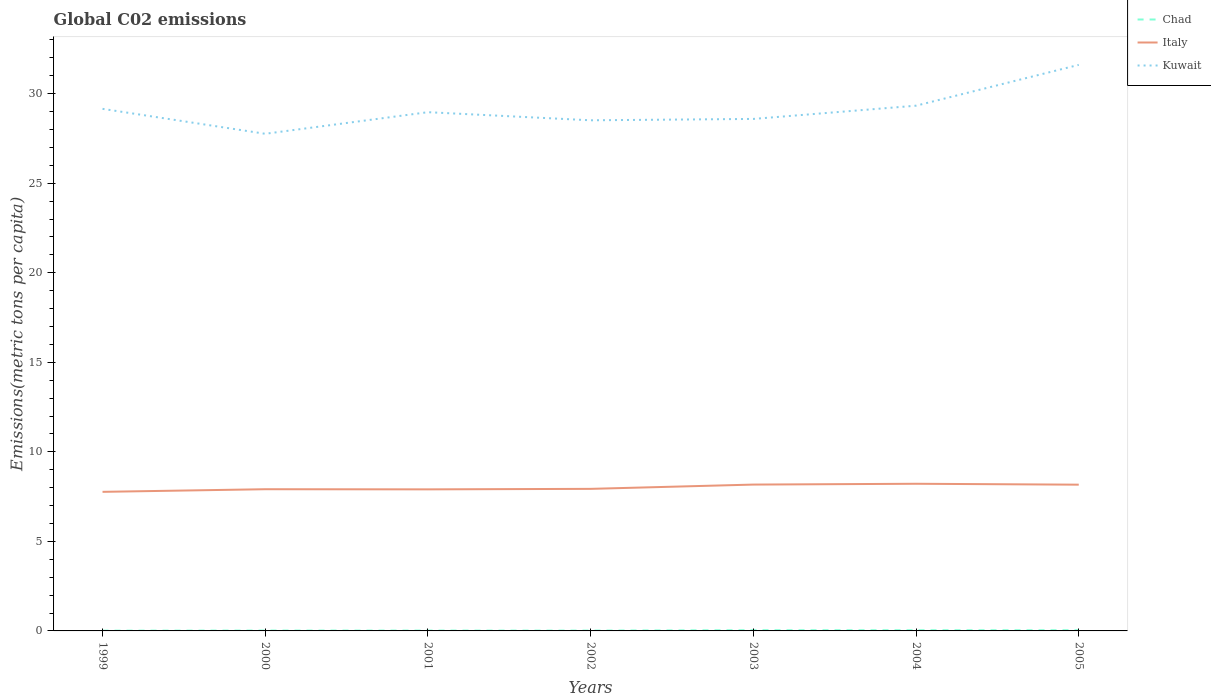How many different coloured lines are there?
Ensure brevity in your answer.  3. Is the number of lines equal to the number of legend labels?
Ensure brevity in your answer.  Yes. Across all years, what is the maximum amount of CO2 emitted in in Chad?
Provide a short and direct response. 0.02. In which year was the amount of CO2 emitted in in Italy maximum?
Keep it short and to the point. 1999. What is the total amount of CO2 emitted in in Italy in the graph?
Make the answer very short. -0.25. What is the difference between the highest and the second highest amount of CO2 emitted in in Chad?
Offer a terse response. 0.03. Is the amount of CO2 emitted in in Kuwait strictly greater than the amount of CO2 emitted in in Italy over the years?
Offer a terse response. No. How many lines are there?
Provide a short and direct response. 3. Are the values on the major ticks of Y-axis written in scientific E-notation?
Provide a succinct answer. No. Does the graph contain grids?
Offer a terse response. No. Where does the legend appear in the graph?
Ensure brevity in your answer.  Top right. How many legend labels are there?
Give a very brief answer. 3. What is the title of the graph?
Your answer should be very brief. Global C02 emissions. Does "Dominica" appear as one of the legend labels in the graph?
Offer a very short reply. No. What is the label or title of the X-axis?
Provide a succinct answer. Years. What is the label or title of the Y-axis?
Keep it short and to the point. Emissions(metric tons per capita). What is the Emissions(metric tons per capita) in Chad in 1999?
Your answer should be compact. 0.02. What is the Emissions(metric tons per capita) in Italy in 1999?
Your answer should be compact. 7.77. What is the Emissions(metric tons per capita) in Kuwait in 1999?
Provide a short and direct response. 29.15. What is the Emissions(metric tons per capita) of Chad in 2000?
Your answer should be compact. 0.02. What is the Emissions(metric tons per capita) of Italy in 2000?
Your response must be concise. 7.91. What is the Emissions(metric tons per capita) in Kuwait in 2000?
Provide a short and direct response. 27.76. What is the Emissions(metric tons per capita) of Chad in 2001?
Offer a terse response. 0.02. What is the Emissions(metric tons per capita) of Italy in 2001?
Keep it short and to the point. 7.9. What is the Emissions(metric tons per capita) of Kuwait in 2001?
Make the answer very short. 28.97. What is the Emissions(metric tons per capita) of Chad in 2002?
Provide a short and direct response. 0.02. What is the Emissions(metric tons per capita) in Italy in 2002?
Provide a succinct answer. 7.93. What is the Emissions(metric tons per capita) in Kuwait in 2002?
Offer a very short reply. 28.51. What is the Emissions(metric tons per capita) of Chad in 2003?
Offer a terse response. 0.04. What is the Emissions(metric tons per capita) of Italy in 2003?
Keep it short and to the point. 8.17. What is the Emissions(metric tons per capita) of Kuwait in 2003?
Your response must be concise. 28.59. What is the Emissions(metric tons per capita) in Chad in 2004?
Make the answer very short. 0.04. What is the Emissions(metric tons per capita) of Italy in 2004?
Your response must be concise. 8.22. What is the Emissions(metric tons per capita) in Kuwait in 2004?
Give a very brief answer. 29.33. What is the Emissions(metric tons per capita) in Chad in 2005?
Your response must be concise. 0.04. What is the Emissions(metric tons per capita) in Italy in 2005?
Provide a succinct answer. 8.17. What is the Emissions(metric tons per capita) of Kuwait in 2005?
Offer a very short reply. 31.61. Across all years, what is the maximum Emissions(metric tons per capita) in Chad?
Provide a succinct answer. 0.04. Across all years, what is the maximum Emissions(metric tons per capita) in Italy?
Your answer should be compact. 8.22. Across all years, what is the maximum Emissions(metric tons per capita) in Kuwait?
Provide a succinct answer. 31.61. Across all years, what is the minimum Emissions(metric tons per capita) of Chad?
Keep it short and to the point. 0.02. Across all years, what is the minimum Emissions(metric tons per capita) of Italy?
Offer a very short reply. 7.77. Across all years, what is the minimum Emissions(metric tons per capita) in Kuwait?
Ensure brevity in your answer.  27.76. What is the total Emissions(metric tons per capita) in Chad in the graph?
Your answer should be compact. 0.19. What is the total Emissions(metric tons per capita) in Italy in the graph?
Your answer should be compact. 56.07. What is the total Emissions(metric tons per capita) in Kuwait in the graph?
Your answer should be compact. 203.91. What is the difference between the Emissions(metric tons per capita) in Chad in 1999 and that in 2000?
Your answer should be very brief. -0.01. What is the difference between the Emissions(metric tons per capita) of Italy in 1999 and that in 2000?
Your answer should be compact. -0.15. What is the difference between the Emissions(metric tons per capita) of Kuwait in 1999 and that in 2000?
Your response must be concise. 1.39. What is the difference between the Emissions(metric tons per capita) in Chad in 1999 and that in 2001?
Give a very brief answer. -0. What is the difference between the Emissions(metric tons per capita) of Italy in 1999 and that in 2001?
Ensure brevity in your answer.  -0.14. What is the difference between the Emissions(metric tons per capita) of Kuwait in 1999 and that in 2001?
Ensure brevity in your answer.  0.19. What is the difference between the Emissions(metric tons per capita) in Chad in 1999 and that in 2002?
Provide a short and direct response. -0. What is the difference between the Emissions(metric tons per capita) in Italy in 1999 and that in 2002?
Your answer should be very brief. -0.17. What is the difference between the Emissions(metric tons per capita) of Kuwait in 1999 and that in 2002?
Offer a terse response. 0.64. What is the difference between the Emissions(metric tons per capita) of Chad in 1999 and that in 2003?
Give a very brief answer. -0.03. What is the difference between the Emissions(metric tons per capita) in Italy in 1999 and that in 2003?
Keep it short and to the point. -0.41. What is the difference between the Emissions(metric tons per capita) in Kuwait in 1999 and that in 2003?
Your answer should be very brief. 0.56. What is the difference between the Emissions(metric tons per capita) of Chad in 1999 and that in 2004?
Your answer should be compact. -0.02. What is the difference between the Emissions(metric tons per capita) of Italy in 1999 and that in 2004?
Give a very brief answer. -0.45. What is the difference between the Emissions(metric tons per capita) in Kuwait in 1999 and that in 2004?
Your answer should be very brief. -0.18. What is the difference between the Emissions(metric tons per capita) of Chad in 1999 and that in 2005?
Provide a short and direct response. -0.02. What is the difference between the Emissions(metric tons per capita) of Italy in 1999 and that in 2005?
Your answer should be very brief. -0.4. What is the difference between the Emissions(metric tons per capita) of Kuwait in 1999 and that in 2005?
Your response must be concise. -2.46. What is the difference between the Emissions(metric tons per capita) of Chad in 2000 and that in 2001?
Offer a very short reply. 0. What is the difference between the Emissions(metric tons per capita) of Italy in 2000 and that in 2001?
Offer a very short reply. 0.01. What is the difference between the Emissions(metric tons per capita) of Kuwait in 2000 and that in 2001?
Keep it short and to the point. -1.21. What is the difference between the Emissions(metric tons per capita) in Chad in 2000 and that in 2002?
Your answer should be very brief. 0. What is the difference between the Emissions(metric tons per capita) in Italy in 2000 and that in 2002?
Offer a terse response. -0.02. What is the difference between the Emissions(metric tons per capita) of Kuwait in 2000 and that in 2002?
Your response must be concise. -0.75. What is the difference between the Emissions(metric tons per capita) in Chad in 2000 and that in 2003?
Give a very brief answer. -0.02. What is the difference between the Emissions(metric tons per capita) of Italy in 2000 and that in 2003?
Your answer should be very brief. -0.26. What is the difference between the Emissions(metric tons per capita) in Kuwait in 2000 and that in 2003?
Provide a succinct answer. -0.83. What is the difference between the Emissions(metric tons per capita) of Chad in 2000 and that in 2004?
Make the answer very short. -0.02. What is the difference between the Emissions(metric tons per capita) of Italy in 2000 and that in 2004?
Offer a very short reply. -0.3. What is the difference between the Emissions(metric tons per capita) in Kuwait in 2000 and that in 2004?
Make the answer very short. -1.57. What is the difference between the Emissions(metric tons per capita) of Chad in 2000 and that in 2005?
Offer a very short reply. -0.02. What is the difference between the Emissions(metric tons per capita) in Italy in 2000 and that in 2005?
Your answer should be very brief. -0.25. What is the difference between the Emissions(metric tons per capita) in Kuwait in 2000 and that in 2005?
Your answer should be very brief. -3.85. What is the difference between the Emissions(metric tons per capita) in Chad in 2001 and that in 2002?
Your answer should be very brief. 0. What is the difference between the Emissions(metric tons per capita) of Italy in 2001 and that in 2002?
Offer a terse response. -0.03. What is the difference between the Emissions(metric tons per capita) of Kuwait in 2001 and that in 2002?
Make the answer very short. 0.45. What is the difference between the Emissions(metric tons per capita) of Chad in 2001 and that in 2003?
Offer a very short reply. -0.02. What is the difference between the Emissions(metric tons per capita) in Italy in 2001 and that in 2003?
Give a very brief answer. -0.27. What is the difference between the Emissions(metric tons per capita) of Kuwait in 2001 and that in 2003?
Provide a short and direct response. 0.38. What is the difference between the Emissions(metric tons per capita) of Chad in 2001 and that in 2004?
Your response must be concise. -0.02. What is the difference between the Emissions(metric tons per capita) in Italy in 2001 and that in 2004?
Your answer should be compact. -0.31. What is the difference between the Emissions(metric tons per capita) in Kuwait in 2001 and that in 2004?
Keep it short and to the point. -0.36. What is the difference between the Emissions(metric tons per capita) in Chad in 2001 and that in 2005?
Your response must be concise. -0.02. What is the difference between the Emissions(metric tons per capita) in Italy in 2001 and that in 2005?
Ensure brevity in your answer.  -0.26. What is the difference between the Emissions(metric tons per capita) in Kuwait in 2001 and that in 2005?
Your response must be concise. -2.64. What is the difference between the Emissions(metric tons per capita) of Chad in 2002 and that in 2003?
Your answer should be compact. -0.02. What is the difference between the Emissions(metric tons per capita) of Italy in 2002 and that in 2003?
Give a very brief answer. -0.24. What is the difference between the Emissions(metric tons per capita) in Kuwait in 2002 and that in 2003?
Your answer should be compact. -0.08. What is the difference between the Emissions(metric tons per capita) of Chad in 2002 and that in 2004?
Your answer should be compact. -0.02. What is the difference between the Emissions(metric tons per capita) of Italy in 2002 and that in 2004?
Give a very brief answer. -0.28. What is the difference between the Emissions(metric tons per capita) in Kuwait in 2002 and that in 2004?
Provide a succinct answer. -0.82. What is the difference between the Emissions(metric tons per capita) in Chad in 2002 and that in 2005?
Make the answer very short. -0.02. What is the difference between the Emissions(metric tons per capita) of Italy in 2002 and that in 2005?
Keep it short and to the point. -0.23. What is the difference between the Emissions(metric tons per capita) in Kuwait in 2002 and that in 2005?
Your answer should be very brief. -3.1. What is the difference between the Emissions(metric tons per capita) of Chad in 2003 and that in 2004?
Your answer should be compact. 0. What is the difference between the Emissions(metric tons per capita) in Italy in 2003 and that in 2004?
Offer a terse response. -0.04. What is the difference between the Emissions(metric tons per capita) of Kuwait in 2003 and that in 2004?
Your answer should be very brief. -0.74. What is the difference between the Emissions(metric tons per capita) in Chad in 2003 and that in 2005?
Provide a short and direct response. 0. What is the difference between the Emissions(metric tons per capita) in Italy in 2003 and that in 2005?
Provide a succinct answer. 0.01. What is the difference between the Emissions(metric tons per capita) of Kuwait in 2003 and that in 2005?
Your response must be concise. -3.02. What is the difference between the Emissions(metric tons per capita) of Chad in 2004 and that in 2005?
Offer a terse response. -0. What is the difference between the Emissions(metric tons per capita) of Italy in 2004 and that in 2005?
Your response must be concise. 0.05. What is the difference between the Emissions(metric tons per capita) in Kuwait in 2004 and that in 2005?
Keep it short and to the point. -2.28. What is the difference between the Emissions(metric tons per capita) of Chad in 1999 and the Emissions(metric tons per capita) of Italy in 2000?
Your answer should be compact. -7.9. What is the difference between the Emissions(metric tons per capita) in Chad in 1999 and the Emissions(metric tons per capita) in Kuwait in 2000?
Provide a succinct answer. -27.74. What is the difference between the Emissions(metric tons per capita) in Italy in 1999 and the Emissions(metric tons per capita) in Kuwait in 2000?
Provide a succinct answer. -19.99. What is the difference between the Emissions(metric tons per capita) in Chad in 1999 and the Emissions(metric tons per capita) in Italy in 2001?
Your response must be concise. -7.89. What is the difference between the Emissions(metric tons per capita) in Chad in 1999 and the Emissions(metric tons per capita) in Kuwait in 2001?
Provide a succinct answer. -28.95. What is the difference between the Emissions(metric tons per capita) in Italy in 1999 and the Emissions(metric tons per capita) in Kuwait in 2001?
Your response must be concise. -21.2. What is the difference between the Emissions(metric tons per capita) in Chad in 1999 and the Emissions(metric tons per capita) in Italy in 2002?
Your answer should be compact. -7.92. What is the difference between the Emissions(metric tons per capita) of Chad in 1999 and the Emissions(metric tons per capita) of Kuwait in 2002?
Ensure brevity in your answer.  -28.5. What is the difference between the Emissions(metric tons per capita) of Italy in 1999 and the Emissions(metric tons per capita) of Kuwait in 2002?
Provide a succinct answer. -20.75. What is the difference between the Emissions(metric tons per capita) in Chad in 1999 and the Emissions(metric tons per capita) in Italy in 2003?
Offer a very short reply. -8.16. What is the difference between the Emissions(metric tons per capita) in Chad in 1999 and the Emissions(metric tons per capita) in Kuwait in 2003?
Keep it short and to the point. -28.57. What is the difference between the Emissions(metric tons per capita) of Italy in 1999 and the Emissions(metric tons per capita) of Kuwait in 2003?
Offer a terse response. -20.82. What is the difference between the Emissions(metric tons per capita) in Chad in 1999 and the Emissions(metric tons per capita) in Italy in 2004?
Offer a very short reply. -8.2. What is the difference between the Emissions(metric tons per capita) in Chad in 1999 and the Emissions(metric tons per capita) in Kuwait in 2004?
Give a very brief answer. -29.31. What is the difference between the Emissions(metric tons per capita) in Italy in 1999 and the Emissions(metric tons per capita) in Kuwait in 2004?
Keep it short and to the point. -21.56. What is the difference between the Emissions(metric tons per capita) of Chad in 1999 and the Emissions(metric tons per capita) of Italy in 2005?
Your answer should be compact. -8.15. What is the difference between the Emissions(metric tons per capita) of Chad in 1999 and the Emissions(metric tons per capita) of Kuwait in 2005?
Provide a short and direct response. -31.59. What is the difference between the Emissions(metric tons per capita) of Italy in 1999 and the Emissions(metric tons per capita) of Kuwait in 2005?
Provide a short and direct response. -23.84. What is the difference between the Emissions(metric tons per capita) of Chad in 2000 and the Emissions(metric tons per capita) of Italy in 2001?
Keep it short and to the point. -7.88. What is the difference between the Emissions(metric tons per capita) of Chad in 2000 and the Emissions(metric tons per capita) of Kuwait in 2001?
Keep it short and to the point. -28.94. What is the difference between the Emissions(metric tons per capita) in Italy in 2000 and the Emissions(metric tons per capita) in Kuwait in 2001?
Your response must be concise. -21.05. What is the difference between the Emissions(metric tons per capita) in Chad in 2000 and the Emissions(metric tons per capita) in Italy in 2002?
Make the answer very short. -7.91. What is the difference between the Emissions(metric tons per capita) of Chad in 2000 and the Emissions(metric tons per capita) of Kuwait in 2002?
Ensure brevity in your answer.  -28.49. What is the difference between the Emissions(metric tons per capita) in Italy in 2000 and the Emissions(metric tons per capita) in Kuwait in 2002?
Your answer should be very brief. -20.6. What is the difference between the Emissions(metric tons per capita) of Chad in 2000 and the Emissions(metric tons per capita) of Italy in 2003?
Offer a terse response. -8.15. What is the difference between the Emissions(metric tons per capita) in Chad in 2000 and the Emissions(metric tons per capita) in Kuwait in 2003?
Your answer should be very brief. -28.57. What is the difference between the Emissions(metric tons per capita) in Italy in 2000 and the Emissions(metric tons per capita) in Kuwait in 2003?
Offer a terse response. -20.68. What is the difference between the Emissions(metric tons per capita) in Chad in 2000 and the Emissions(metric tons per capita) in Italy in 2004?
Offer a terse response. -8.2. What is the difference between the Emissions(metric tons per capita) in Chad in 2000 and the Emissions(metric tons per capita) in Kuwait in 2004?
Your answer should be very brief. -29.31. What is the difference between the Emissions(metric tons per capita) of Italy in 2000 and the Emissions(metric tons per capita) of Kuwait in 2004?
Give a very brief answer. -21.42. What is the difference between the Emissions(metric tons per capita) of Chad in 2000 and the Emissions(metric tons per capita) of Italy in 2005?
Give a very brief answer. -8.14. What is the difference between the Emissions(metric tons per capita) of Chad in 2000 and the Emissions(metric tons per capita) of Kuwait in 2005?
Your answer should be very brief. -31.59. What is the difference between the Emissions(metric tons per capita) in Italy in 2000 and the Emissions(metric tons per capita) in Kuwait in 2005?
Offer a very short reply. -23.69. What is the difference between the Emissions(metric tons per capita) in Chad in 2001 and the Emissions(metric tons per capita) in Italy in 2002?
Provide a succinct answer. -7.91. What is the difference between the Emissions(metric tons per capita) of Chad in 2001 and the Emissions(metric tons per capita) of Kuwait in 2002?
Give a very brief answer. -28.49. What is the difference between the Emissions(metric tons per capita) of Italy in 2001 and the Emissions(metric tons per capita) of Kuwait in 2002?
Provide a short and direct response. -20.61. What is the difference between the Emissions(metric tons per capita) of Chad in 2001 and the Emissions(metric tons per capita) of Italy in 2003?
Your answer should be very brief. -8.15. What is the difference between the Emissions(metric tons per capita) in Chad in 2001 and the Emissions(metric tons per capita) in Kuwait in 2003?
Your answer should be compact. -28.57. What is the difference between the Emissions(metric tons per capita) in Italy in 2001 and the Emissions(metric tons per capita) in Kuwait in 2003?
Offer a very short reply. -20.68. What is the difference between the Emissions(metric tons per capita) of Chad in 2001 and the Emissions(metric tons per capita) of Italy in 2004?
Offer a very short reply. -8.2. What is the difference between the Emissions(metric tons per capita) of Chad in 2001 and the Emissions(metric tons per capita) of Kuwait in 2004?
Make the answer very short. -29.31. What is the difference between the Emissions(metric tons per capita) in Italy in 2001 and the Emissions(metric tons per capita) in Kuwait in 2004?
Ensure brevity in your answer.  -21.42. What is the difference between the Emissions(metric tons per capita) in Chad in 2001 and the Emissions(metric tons per capita) in Italy in 2005?
Give a very brief answer. -8.15. What is the difference between the Emissions(metric tons per capita) in Chad in 2001 and the Emissions(metric tons per capita) in Kuwait in 2005?
Your response must be concise. -31.59. What is the difference between the Emissions(metric tons per capita) in Italy in 2001 and the Emissions(metric tons per capita) in Kuwait in 2005?
Your answer should be compact. -23.7. What is the difference between the Emissions(metric tons per capita) in Chad in 2002 and the Emissions(metric tons per capita) in Italy in 2003?
Provide a short and direct response. -8.15. What is the difference between the Emissions(metric tons per capita) of Chad in 2002 and the Emissions(metric tons per capita) of Kuwait in 2003?
Offer a very short reply. -28.57. What is the difference between the Emissions(metric tons per capita) of Italy in 2002 and the Emissions(metric tons per capita) of Kuwait in 2003?
Give a very brief answer. -20.66. What is the difference between the Emissions(metric tons per capita) of Chad in 2002 and the Emissions(metric tons per capita) of Italy in 2004?
Offer a very short reply. -8.2. What is the difference between the Emissions(metric tons per capita) of Chad in 2002 and the Emissions(metric tons per capita) of Kuwait in 2004?
Your answer should be very brief. -29.31. What is the difference between the Emissions(metric tons per capita) of Italy in 2002 and the Emissions(metric tons per capita) of Kuwait in 2004?
Provide a short and direct response. -21.4. What is the difference between the Emissions(metric tons per capita) in Chad in 2002 and the Emissions(metric tons per capita) in Italy in 2005?
Your answer should be very brief. -8.15. What is the difference between the Emissions(metric tons per capita) of Chad in 2002 and the Emissions(metric tons per capita) of Kuwait in 2005?
Ensure brevity in your answer.  -31.59. What is the difference between the Emissions(metric tons per capita) in Italy in 2002 and the Emissions(metric tons per capita) in Kuwait in 2005?
Offer a terse response. -23.68. What is the difference between the Emissions(metric tons per capita) in Chad in 2003 and the Emissions(metric tons per capita) in Italy in 2004?
Your response must be concise. -8.18. What is the difference between the Emissions(metric tons per capita) in Chad in 2003 and the Emissions(metric tons per capita) in Kuwait in 2004?
Your response must be concise. -29.29. What is the difference between the Emissions(metric tons per capita) of Italy in 2003 and the Emissions(metric tons per capita) of Kuwait in 2004?
Make the answer very short. -21.16. What is the difference between the Emissions(metric tons per capita) in Chad in 2003 and the Emissions(metric tons per capita) in Italy in 2005?
Keep it short and to the point. -8.13. What is the difference between the Emissions(metric tons per capita) in Chad in 2003 and the Emissions(metric tons per capita) in Kuwait in 2005?
Your answer should be compact. -31.57. What is the difference between the Emissions(metric tons per capita) in Italy in 2003 and the Emissions(metric tons per capita) in Kuwait in 2005?
Provide a short and direct response. -23.44. What is the difference between the Emissions(metric tons per capita) in Chad in 2004 and the Emissions(metric tons per capita) in Italy in 2005?
Provide a short and direct response. -8.13. What is the difference between the Emissions(metric tons per capita) of Chad in 2004 and the Emissions(metric tons per capita) of Kuwait in 2005?
Give a very brief answer. -31.57. What is the difference between the Emissions(metric tons per capita) of Italy in 2004 and the Emissions(metric tons per capita) of Kuwait in 2005?
Provide a short and direct response. -23.39. What is the average Emissions(metric tons per capita) in Chad per year?
Make the answer very short. 0.03. What is the average Emissions(metric tons per capita) of Italy per year?
Keep it short and to the point. 8.01. What is the average Emissions(metric tons per capita) of Kuwait per year?
Provide a succinct answer. 29.13. In the year 1999, what is the difference between the Emissions(metric tons per capita) of Chad and Emissions(metric tons per capita) of Italy?
Keep it short and to the point. -7.75. In the year 1999, what is the difference between the Emissions(metric tons per capita) in Chad and Emissions(metric tons per capita) in Kuwait?
Give a very brief answer. -29.14. In the year 1999, what is the difference between the Emissions(metric tons per capita) in Italy and Emissions(metric tons per capita) in Kuwait?
Make the answer very short. -21.39. In the year 2000, what is the difference between the Emissions(metric tons per capita) of Chad and Emissions(metric tons per capita) of Italy?
Your answer should be very brief. -7.89. In the year 2000, what is the difference between the Emissions(metric tons per capita) of Chad and Emissions(metric tons per capita) of Kuwait?
Your answer should be very brief. -27.74. In the year 2000, what is the difference between the Emissions(metric tons per capita) in Italy and Emissions(metric tons per capita) in Kuwait?
Offer a very short reply. -19.85. In the year 2001, what is the difference between the Emissions(metric tons per capita) in Chad and Emissions(metric tons per capita) in Italy?
Give a very brief answer. -7.88. In the year 2001, what is the difference between the Emissions(metric tons per capita) of Chad and Emissions(metric tons per capita) of Kuwait?
Give a very brief answer. -28.95. In the year 2001, what is the difference between the Emissions(metric tons per capita) in Italy and Emissions(metric tons per capita) in Kuwait?
Your answer should be very brief. -21.06. In the year 2002, what is the difference between the Emissions(metric tons per capita) in Chad and Emissions(metric tons per capita) in Italy?
Your answer should be very brief. -7.91. In the year 2002, what is the difference between the Emissions(metric tons per capita) of Chad and Emissions(metric tons per capita) of Kuwait?
Give a very brief answer. -28.49. In the year 2002, what is the difference between the Emissions(metric tons per capita) of Italy and Emissions(metric tons per capita) of Kuwait?
Give a very brief answer. -20.58. In the year 2003, what is the difference between the Emissions(metric tons per capita) in Chad and Emissions(metric tons per capita) in Italy?
Provide a short and direct response. -8.13. In the year 2003, what is the difference between the Emissions(metric tons per capita) of Chad and Emissions(metric tons per capita) of Kuwait?
Make the answer very short. -28.55. In the year 2003, what is the difference between the Emissions(metric tons per capita) in Italy and Emissions(metric tons per capita) in Kuwait?
Your answer should be very brief. -20.42. In the year 2004, what is the difference between the Emissions(metric tons per capita) in Chad and Emissions(metric tons per capita) in Italy?
Ensure brevity in your answer.  -8.18. In the year 2004, what is the difference between the Emissions(metric tons per capita) in Chad and Emissions(metric tons per capita) in Kuwait?
Offer a terse response. -29.29. In the year 2004, what is the difference between the Emissions(metric tons per capita) of Italy and Emissions(metric tons per capita) of Kuwait?
Your answer should be compact. -21.11. In the year 2005, what is the difference between the Emissions(metric tons per capita) of Chad and Emissions(metric tons per capita) of Italy?
Your answer should be compact. -8.13. In the year 2005, what is the difference between the Emissions(metric tons per capita) of Chad and Emissions(metric tons per capita) of Kuwait?
Make the answer very short. -31.57. In the year 2005, what is the difference between the Emissions(metric tons per capita) in Italy and Emissions(metric tons per capita) in Kuwait?
Provide a succinct answer. -23.44. What is the ratio of the Emissions(metric tons per capita) in Chad in 1999 to that in 2000?
Offer a very short reply. 0.71. What is the ratio of the Emissions(metric tons per capita) of Italy in 1999 to that in 2000?
Ensure brevity in your answer.  0.98. What is the ratio of the Emissions(metric tons per capita) in Kuwait in 1999 to that in 2000?
Your answer should be very brief. 1.05. What is the ratio of the Emissions(metric tons per capita) in Chad in 1999 to that in 2001?
Make the answer very short. 0.76. What is the ratio of the Emissions(metric tons per capita) in Italy in 1999 to that in 2001?
Your response must be concise. 0.98. What is the ratio of the Emissions(metric tons per capita) of Kuwait in 1999 to that in 2001?
Provide a short and direct response. 1.01. What is the ratio of the Emissions(metric tons per capita) in Chad in 1999 to that in 2002?
Make the answer very short. 0.8. What is the ratio of the Emissions(metric tons per capita) in Kuwait in 1999 to that in 2002?
Your response must be concise. 1.02. What is the ratio of the Emissions(metric tons per capita) in Chad in 1999 to that in 2003?
Provide a short and direct response. 0.37. What is the ratio of the Emissions(metric tons per capita) of Italy in 1999 to that in 2003?
Provide a succinct answer. 0.95. What is the ratio of the Emissions(metric tons per capita) of Kuwait in 1999 to that in 2003?
Keep it short and to the point. 1.02. What is the ratio of the Emissions(metric tons per capita) of Chad in 1999 to that in 2004?
Offer a terse response. 0.39. What is the ratio of the Emissions(metric tons per capita) of Italy in 1999 to that in 2004?
Offer a very short reply. 0.95. What is the ratio of the Emissions(metric tons per capita) in Chad in 1999 to that in 2005?
Offer a terse response. 0.38. What is the ratio of the Emissions(metric tons per capita) of Italy in 1999 to that in 2005?
Make the answer very short. 0.95. What is the ratio of the Emissions(metric tons per capita) of Kuwait in 1999 to that in 2005?
Your response must be concise. 0.92. What is the ratio of the Emissions(metric tons per capita) in Chad in 2000 to that in 2001?
Offer a terse response. 1.06. What is the ratio of the Emissions(metric tons per capita) of Kuwait in 2000 to that in 2001?
Provide a short and direct response. 0.96. What is the ratio of the Emissions(metric tons per capita) of Chad in 2000 to that in 2002?
Your answer should be very brief. 1.13. What is the ratio of the Emissions(metric tons per capita) of Italy in 2000 to that in 2002?
Your answer should be very brief. 1. What is the ratio of the Emissions(metric tons per capita) of Kuwait in 2000 to that in 2002?
Keep it short and to the point. 0.97. What is the ratio of the Emissions(metric tons per capita) of Chad in 2000 to that in 2003?
Provide a short and direct response. 0.52. What is the ratio of the Emissions(metric tons per capita) in Italy in 2000 to that in 2003?
Provide a short and direct response. 0.97. What is the ratio of the Emissions(metric tons per capita) of Kuwait in 2000 to that in 2003?
Offer a very short reply. 0.97. What is the ratio of the Emissions(metric tons per capita) in Chad in 2000 to that in 2004?
Keep it short and to the point. 0.54. What is the ratio of the Emissions(metric tons per capita) in Italy in 2000 to that in 2004?
Give a very brief answer. 0.96. What is the ratio of the Emissions(metric tons per capita) in Kuwait in 2000 to that in 2004?
Give a very brief answer. 0.95. What is the ratio of the Emissions(metric tons per capita) in Chad in 2000 to that in 2005?
Your answer should be very brief. 0.53. What is the ratio of the Emissions(metric tons per capita) of Italy in 2000 to that in 2005?
Make the answer very short. 0.97. What is the ratio of the Emissions(metric tons per capita) in Kuwait in 2000 to that in 2005?
Make the answer very short. 0.88. What is the ratio of the Emissions(metric tons per capita) in Chad in 2001 to that in 2002?
Your response must be concise. 1.06. What is the ratio of the Emissions(metric tons per capita) in Italy in 2001 to that in 2002?
Your response must be concise. 1. What is the ratio of the Emissions(metric tons per capita) in Kuwait in 2001 to that in 2002?
Provide a short and direct response. 1.02. What is the ratio of the Emissions(metric tons per capita) of Chad in 2001 to that in 2003?
Provide a succinct answer. 0.49. What is the ratio of the Emissions(metric tons per capita) in Italy in 2001 to that in 2003?
Your response must be concise. 0.97. What is the ratio of the Emissions(metric tons per capita) in Kuwait in 2001 to that in 2003?
Provide a succinct answer. 1.01. What is the ratio of the Emissions(metric tons per capita) of Chad in 2001 to that in 2004?
Give a very brief answer. 0.51. What is the ratio of the Emissions(metric tons per capita) in Kuwait in 2001 to that in 2004?
Ensure brevity in your answer.  0.99. What is the ratio of the Emissions(metric tons per capita) in Chad in 2001 to that in 2005?
Make the answer very short. 0.5. What is the ratio of the Emissions(metric tons per capita) in Italy in 2001 to that in 2005?
Your answer should be very brief. 0.97. What is the ratio of the Emissions(metric tons per capita) in Kuwait in 2001 to that in 2005?
Keep it short and to the point. 0.92. What is the ratio of the Emissions(metric tons per capita) in Chad in 2002 to that in 2003?
Provide a short and direct response. 0.46. What is the ratio of the Emissions(metric tons per capita) in Italy in 2002 to that in 2003?
Offer a terse response. 0.97. What is the ratio of the Emissions(metric tons per capita) in Chad in 2002 to that in 2004?
Keep it short and to the point. 0.48. What is the ratio of the Emissions(metric tons per capita) in Italy in 2002 to that in 2004?
Provide a succinct answer. 0.97. What is the ratio of the Emissions(metric tons per capita) in Kuwait in 2002 to that in 2004?
Give a very brief answer. 0.97. What is the ratio of the Emissions(metric tons per capita) in Chad in 2002 to that in 2005?
Offer a very short reply. 0.47. What is the ratio of the Emissions(metric tons per capita) in Italy in 2002 to that in 2005?
Offer a very short reply. 0.97. What is the ratio of the Emissions(metric tons per capita) of Kuwait in 2002 to that in 2005?
Your response must be concise. 0.9. What is the ratio of the Emissions(metric tons per capita) of Chad in 2003 to that in 2004?
Your response must be concise. 1.05. What is the ratio of the Emissions(metric tons per capita) of Kuwait in 2003 to that in 2004?
Your response must be concise. 0.97. What is the ratio of the Emissions(metric tons per capita) of Chad in 2003 to that in 2005?
Offer a very short reply. 1.03. What is the ratio of the Emissions(metric tons per capita) of Italy in 2003 to that in 2005?
Keep it short and to the point. 1. What is the ratio of the Emissions(metric tons per capita) of Kuwait in 2003 to that in 2005?
Provide a succinct answer. 0.9. What is the ratio of the Emissions(metric tons per capita) of Chad in 2004 to that in 2005?
Your answer should be very brief. 0.98. What is the ratio of the Emissions(metric tons per capita) in Italy in 2004 to that in 2005?
Offer a terse response. 1.01. What is the ratio of the Emissions(metric tons per capita) of Kuwait in 2004 to that in 2005?
Your answer should be very brief. 0.93. What is the difference between the highest and the second highest Emissions(metric tons per capita) of Chad?
Offer a very short reply. 0. What is the difference between the highest and the second highest Emissions(metric tons per capita) in Italy?
Offer a terse response. 0.04. What is the difference between the highest and the second highest Emissions(metric tons per capita) in Kuwait?
Your answer should be very brief. 2.28. What is the difference between the highest and the lowest Emissions(metric tons per capita) in Chad?
Ensure brevity in your answer.  0.03. What is the difference between the highest and the lowest Emissions(metric tons per capita) of Italy?
Offer a terse response. 0.45. What is the difference between the highest and the lowest Emissions(metric tons per capita) in Kuwait?
Make the answer very short. 3.85. 